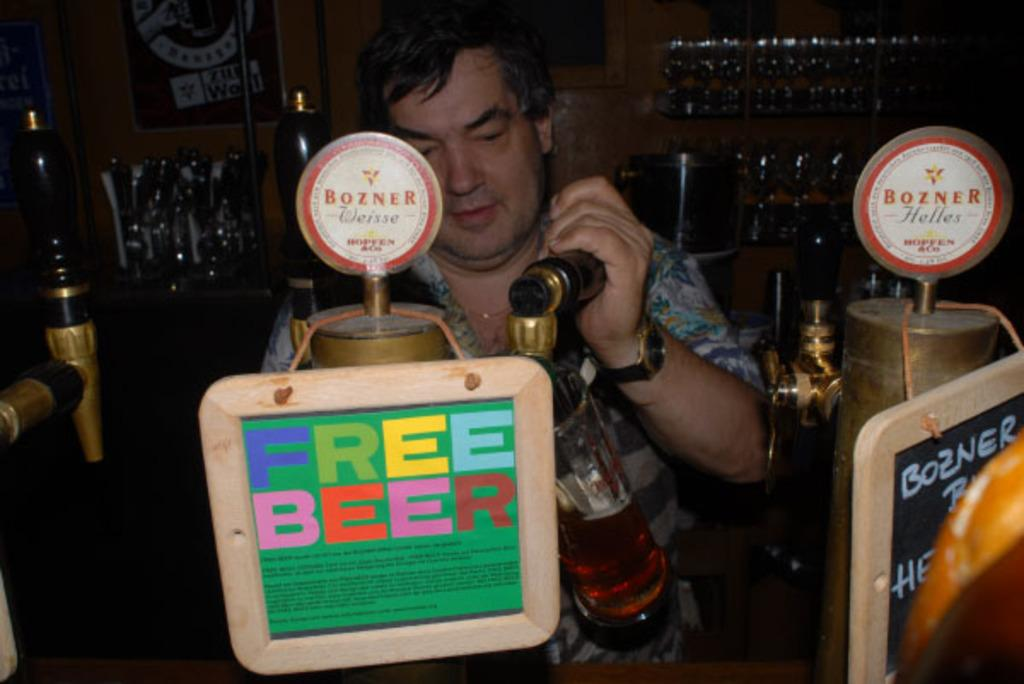<image>
Share a concise interpretation of the image provided. Man filling up beer behind a sign that says "Free Beer". 